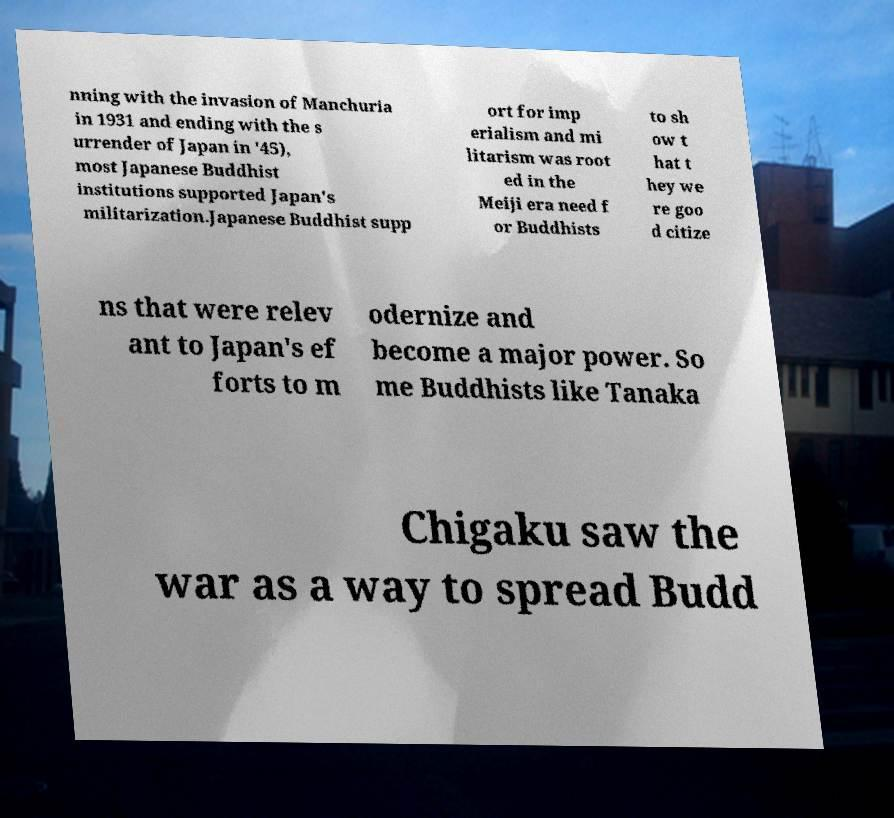Can you accurately transcribe the text from the provided image for me? nning with the invasion of Manchuria in 1931 and ending with the s urrender of Japan in '45), most Japanese Buddhist institutions supported Japan's militarization.Japanese Buddhist supp ort for imp erialism and mi litarism was root ed in the Meiji era need f or Buddhists to sh ow t hat t hey we re goo d citize ns that were relev ant to Japan's ef forts to m odernize and become a major power. So me Buddhists like Tanaka Chigaku saw the war as a way to spread Budd 